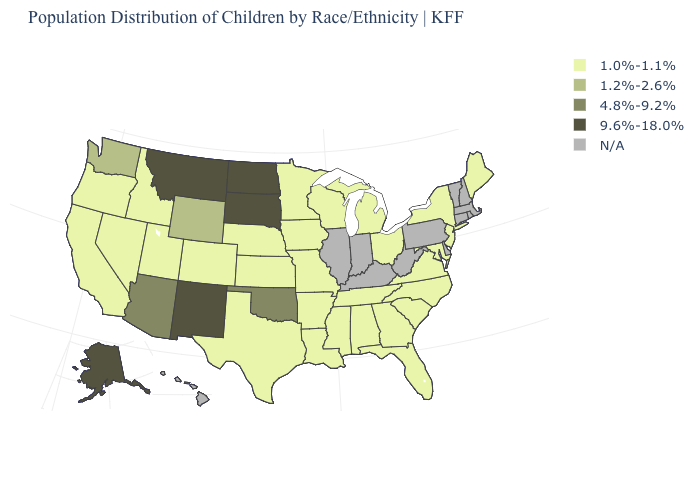What is the value of New Jersey?
Quick response, please. 1.0%-1.1%. What is the value of Mississippi?
Quick response, please. 1.0%-1.1%. Name the states that have a value in the range 1.2%-2.6%?
Be succinct. Washington, Wyoming. Which states have the highest value in the USA?
Give a very brief answer. Alaska, Montana, New Mexico, North Dakota, South Dakota. What is the value of Vermont?
Quick response, please. N/A. What is the value of Washington?
Write a very short answer. 1.2%-2.6%. Does Mississippi have the lowest value in the USA?
Give a very brief answer. Yes. How many symbols are there in the legend?
Answer briefly. 5. Does the map have missing data?
Give a very brief answer. Yes. Among the states that border Indiana , which have the lowest value?
Concise answer only. Michigan, Ohio. Among the states that border Florida , which have the lowest value?
Short answer required. Alabama, Georgia. Which states have the lowest value in the Northeast?
Keep it brief. Maine, New Jersey, New York. 